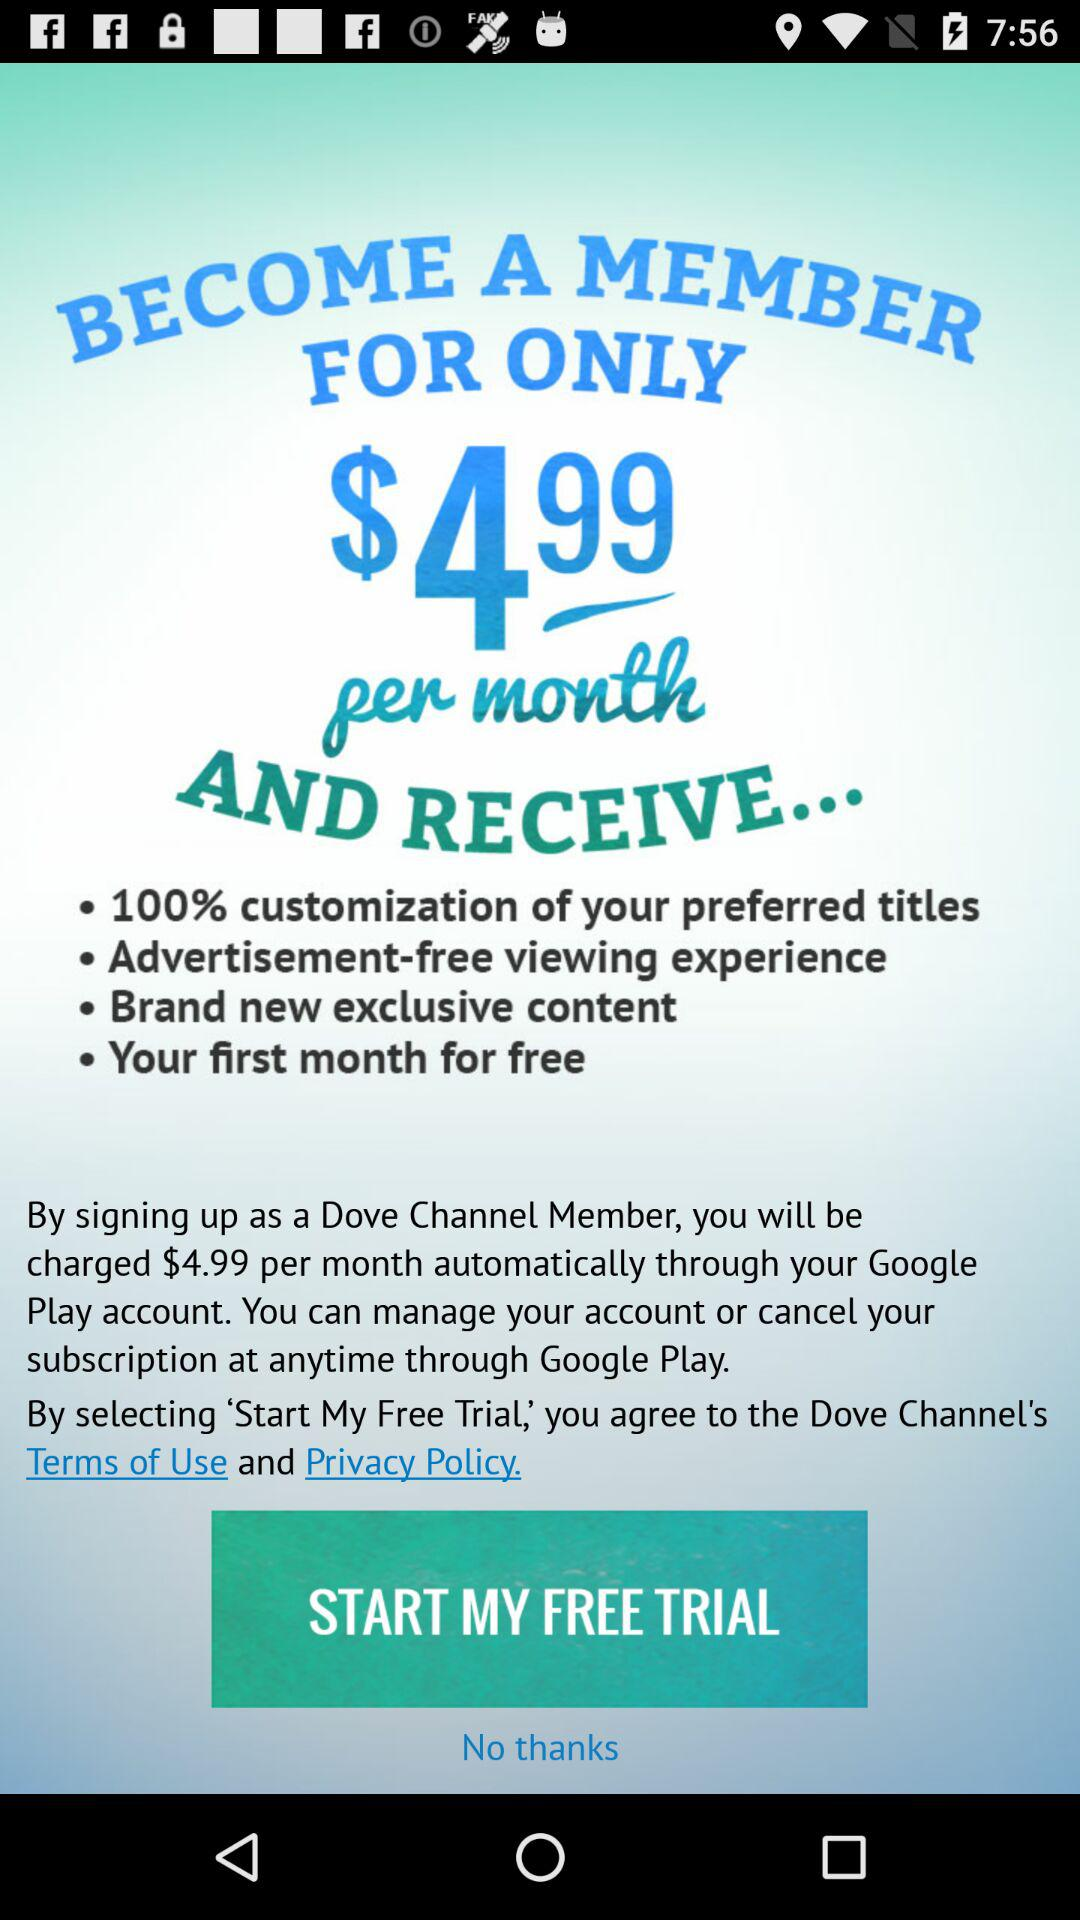What is the per-month charge for membership? The per-month charge for membership is $4.99. 